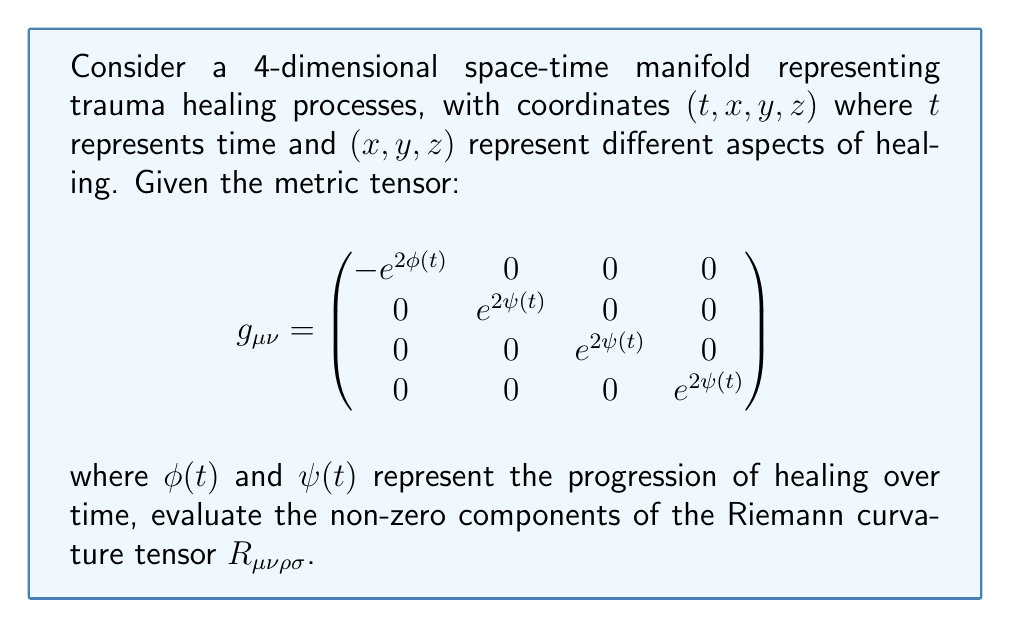Show me your answer to this math problem. To evaluate the Riemann curvature tensor, we'll follow these steps:

1) First, we need to calculate the Christoffel symbols $\Gamma^\mu_{\nu\rho}$ using the formula:

   $$\Gamma^\mu_{\nu\rho} = \frac{1}{2}g^{\mu\sigma}(\partial_\nu g_{\sigma\rho} + \partial_\rho g_{\sigma\nu} - \partial_\sigma g_{\nu\rho})$$

2) Given the metric, the non-zero Christoffel symbols are:

   $$\Gamma^0_{00} = \dot{\phi}, \quad \Gamma^i_{0i} = \Gamma^i_{i0} = \dot{\psi}, \quad \Gamma^0_{ii} = e^{2(\psi-\phi)}\dot{\psi}$$

   where $i = 1, 2, 3$ and dot represents derivative with respect to $t$.

3) Now, we can calculate the Riemann tensor using:

   $$R^\rho_{\sigma\mu\nu} = \partial_\mu\Gamma^\rho_{\nu\sigma} - \partial_\nu\Gamma^\rho_{\mu\sigma} + \Gamma^\rho_{\mu\lambda}\Gamma^\lambda_{\nu\sigma} - \Gamma^\rho_{\nu\lambda}\Gamma^\lambda_{\mu\sigma}$$

4) The non-zero components are:

   $$R^0_{i0i} = -(\ddot{\psi} + \dot{\psi}^2 - \dot{\phi}\dot{\psi})$$
   $$R^i_{0j0} = -e^{2(\phi-\psi)}(\ddot{\psi} + \dot{\psi}^2 - \dot{\phi}\dot{\psi})\delta^i_j$$
   $$R^i_{jkl} = (\dot{\psi}^2 e^{2(\phi-\psi)})(\delta^i_k\delta_{jl} - \delta^i_l\delta_{jk})$$

   where $i, j, k, l = 1, 2, 3$ and $\delta^i_j$ is the Kronecker delta.

5) To lower the first index and get $R_{\mu\nu\rho\sigma}$, we multiply by $g_{\mu\lambda}$:

   $$R_{i0i0} = e^{2\psi}(\ddot{\psi} + \dot{\psi}^2 - \dot{\phi}\dot{\psi})$$
   $$R_{0i0i} = -e^{2\phi}(\ddot{\psi} + \dot{\psi}^2 - \dot{\phi}\dot{\psi})$$
   $$R_{ijkl} = e^{4\psi}\dot{\psi}^2(\delta_{ik}\delta_{jl} - \delta_{il}\delta_{jk})$$
Answer: $R_{i0i0} = e^{2\psi}(\ddot{\psi} + \dot{\psi}^2 - \dot{\phi}\dot{\psi})$, $R_{0i0i} = -e^{2\phi}(\ddot{\psi} + \dot{\psi}^2 - \dot{\phi}\dot{\psi})$, $R_{ijkl} = e^{4\psi}\dot{\psi}^2(\delta_{ik}\delta_{jl} - \delta_{il}\delta_{jk})$ 